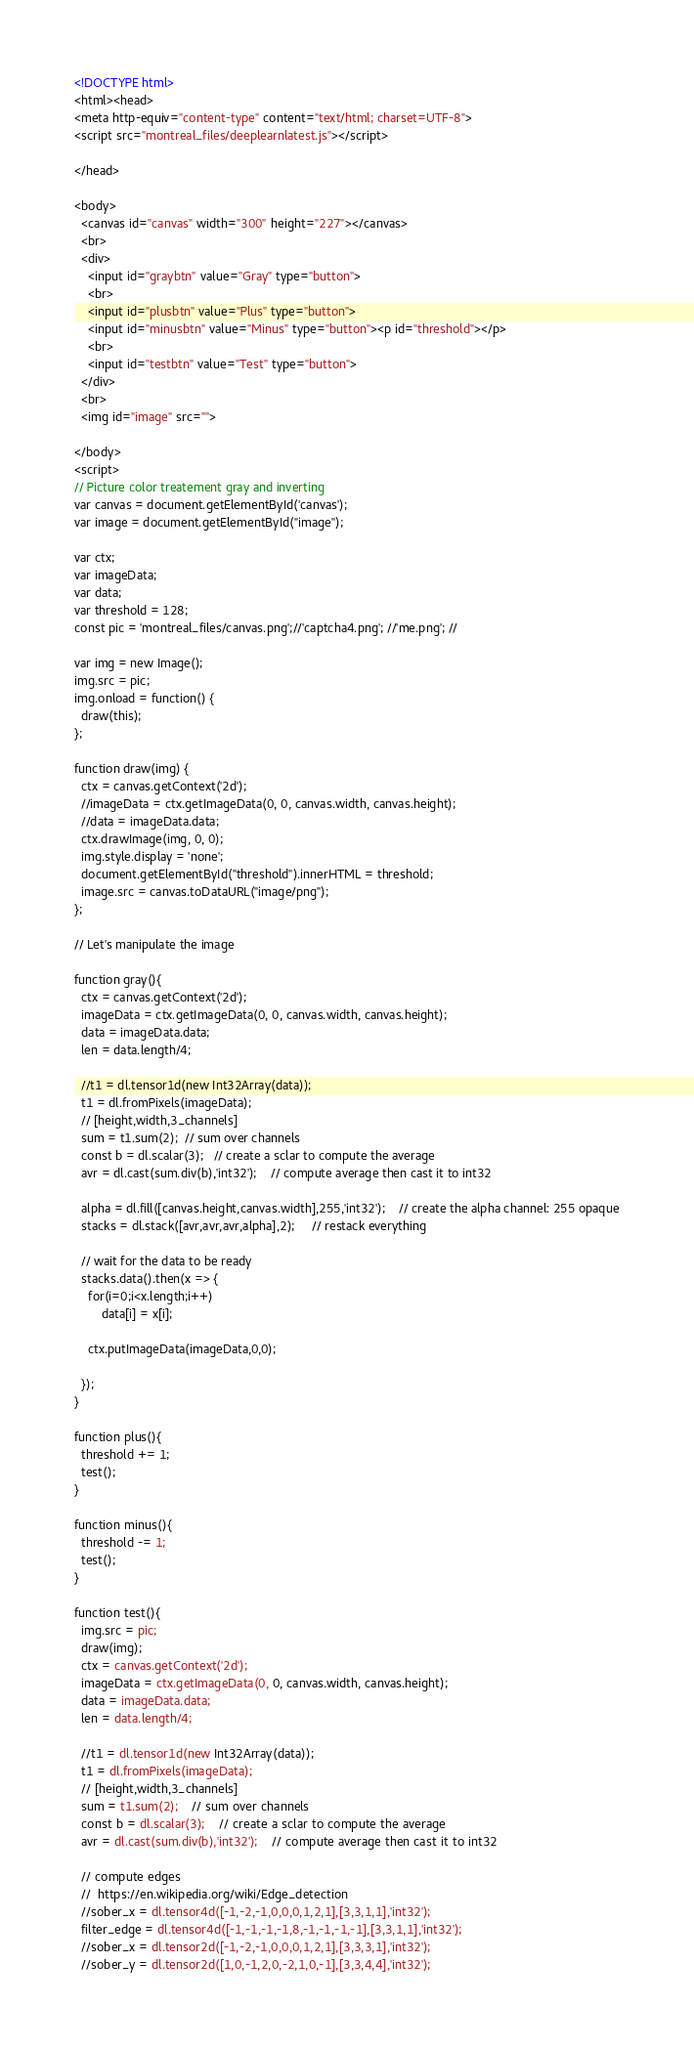Convert code to text. <code><loc_0><loc_0><loc_500><loc_500><_HTML_><!DOCTYPE html>
<html><head>
<meta http-equiv="content-type" content="text/html; charset=UTF-8">
<script src="montreal_files/deeplearnlatest.js"></script>

</head>

<body>
  <canvas id="canvas" width="300" height="227"></canvas>
  <br>
  <div>
    <input id="graybtn" value="Gray" type="button">
	<br>
    <input id="plusbtn" value="Plus" type="button">
	<input id="minusbtn" value="Minus" type="button"><p id="threshold"></p>
    <br>
	<input id="testbtn" value="Test" type="button">
  </div>
  <br>
  <img id="image" src="">

</body>
<script>
// Picture color treatement gray and inverting
var canvas = document.getElementById('canvas');
var image = document.getElementById("image");

var ctx;
var imageData;
var data;
var threshold = 128;
const pic = 'montreal_files/canvas.png';//'captcha4.png'; //'me.png'; //

var img = new Image();
img.src = pic;
img.onload = function() {
  draw(this);
};

function draw(img) {
  ctx = canvas.getContext('2d');
  //imageData = ctx.getImageData(0, 0, canvas.width, canvas.height);
  //data = imageData.data;
  ctx.drawImage(img, 0, 0);
  img.style.display = 'none';
  document.getElementById("threshold").innerHTML = threshold;
  image.src = canvas.toDataURL("image/png");
};

// Let's manipulate the image

function gray(){
  ctx = canvas.getContext('2d');
  imageData = ctx.getImageData(0, 0, canvas.width, canvas.height);
  data = imageData.data;
  len = data.length/4;

  //t1 = dl.tensor1d(new Int32Array(data));
  t1 = dl.fromPixels(imageData);
  // [height,width,3_channels]
  sum = t1.sum(2);	// sum over channels
  const b = dl.scalar(3);	// create a sclar to compute the average
  avr = dl.cast(sum.div(b),'int32');	// compute average then cast it to int32

  alpha = dl.fill([canvas.height,canvas.width],255,'int32');	// create the alpha channel: 255 opaque
  stacks = dl.stack([avr,avr,avr,alpha],2);		// restack everything
  
  // wait for the data to be ready
  stacks.data().then(x => {
	for(i=0;i<x.length;i++)
		data[i] = x[i];
        
	ctx.putImageData(imageData,0,0);

  });
}

function plus(){
  threshold += 1;
  test();
}

function minus(){
  threshold -= 1;
  test();
}

function test(){
  img.src = pic;
  draw(img);
  ctx = canvas.getContext('2d');
  imageData = ctx.getImageData(0, 0, canvas.width, canvas.height);
  data = imageData.data;
  len = data.length/4;

  //t1 = dl.tensor1d(new Int32Array(data));
  t1 = dl.fromPixels(imageData);
  // [height,width,3_channels]
  sum = t1.sum(2);	// sum over channels
  const b = dl.scalar(3);	// create a sclar to compute the average
  avr = dl.cast(sum.div(b),'int32');	// compute average then cast it to int32

  // compute edges
  //  https://en.wikipedia.org/wiki/Edge_detection
  //sober_x = dl.tensor4d([-1,-2,-1,0,0,0,1,2,1],[3,3,1,1],'int32');
  filter_edge = dl.tensor4d([-1,-1,-1,-1,8,-1,-1,-1,-1],[3,3,1,1],'int32');
  //sober_x = dl.tensor2d([-1,-2,-1,0,0,0,1,2,1],[3,3,3,1],'int32');
  //sober_y = dl.tensor2d([1,0,-1,2,0,-2,1,0,-1],[3,3,4,4],'int32');</code> 